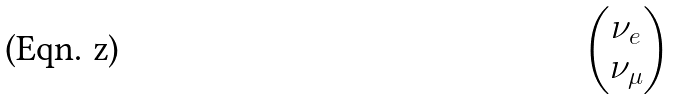Convert formula to latex. <formula><loc_0><loc_0><loc_500><loc_500>\begin{pmatrix} \nu _ { e } \\ \nu _ { \mu } \end{pmatrix}</formula> 